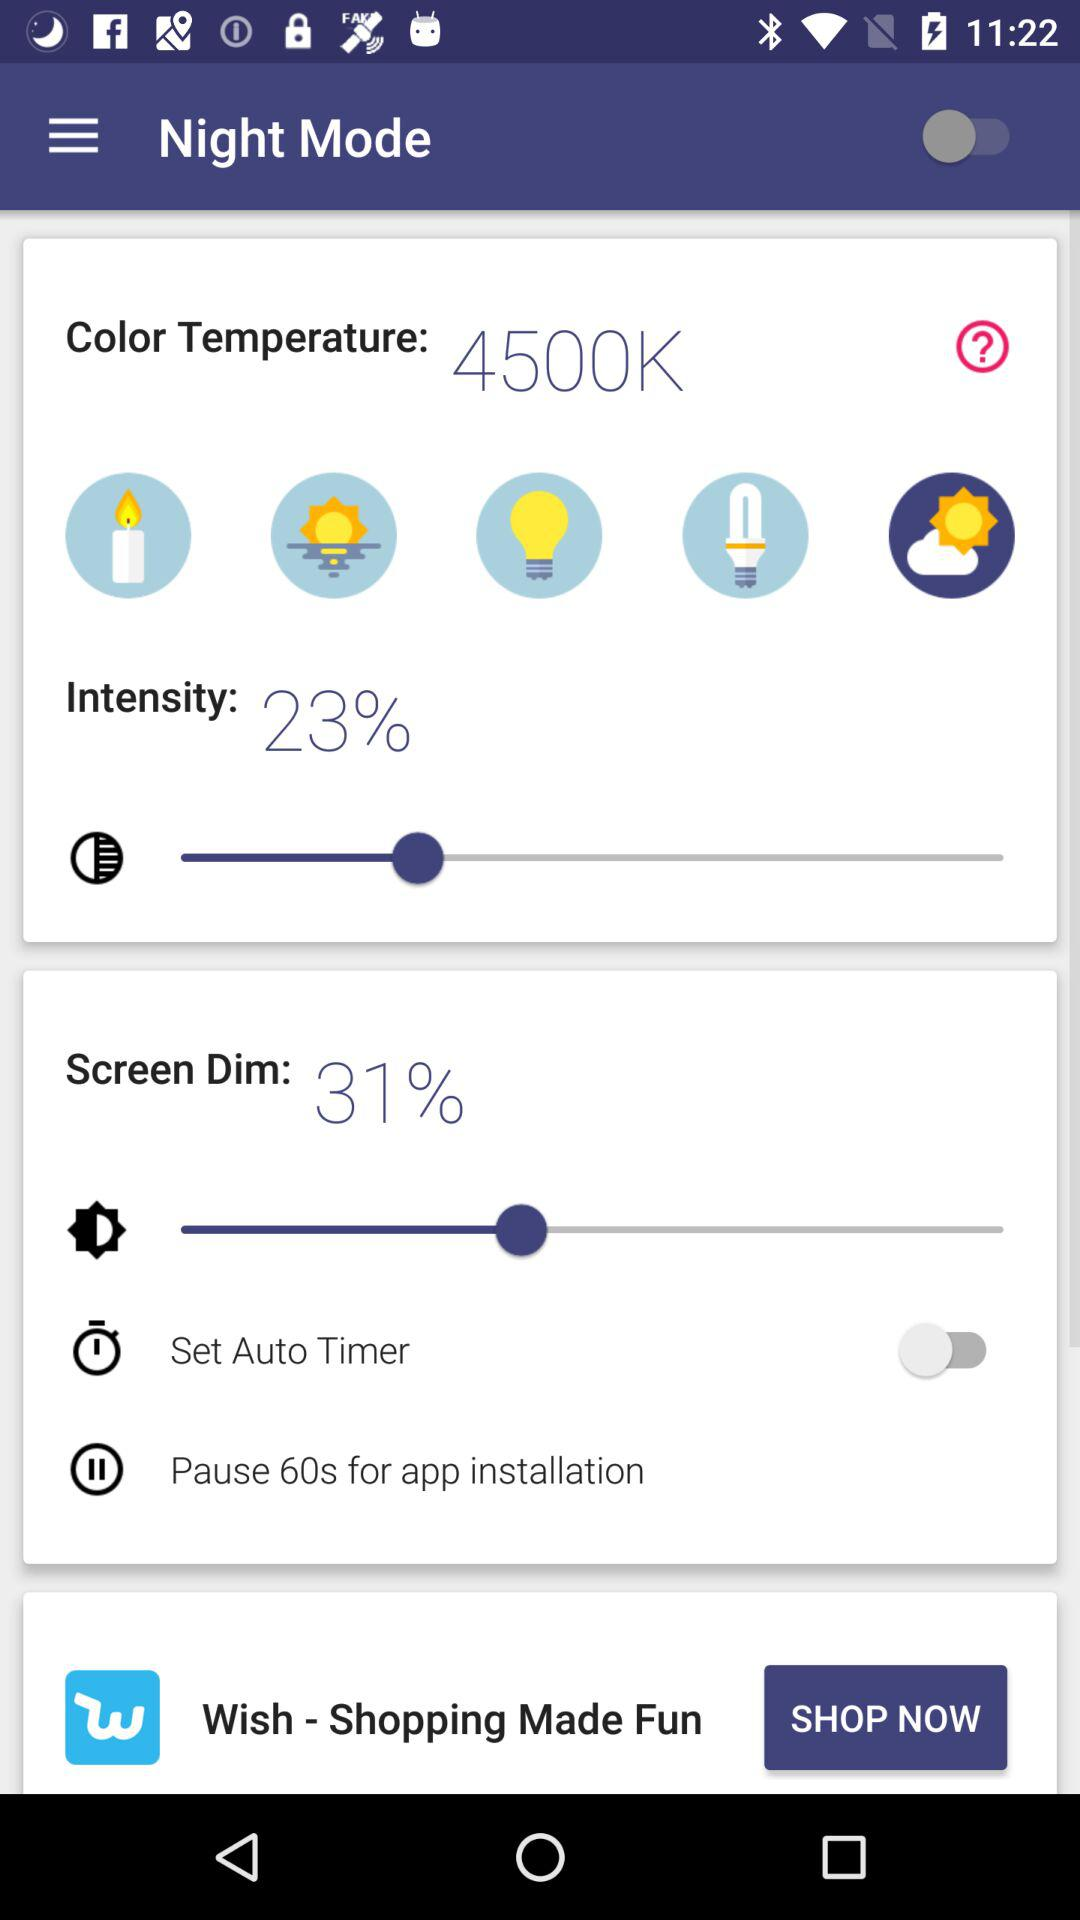What is the current status of "Set Auto Timer"? The current status is "off". 